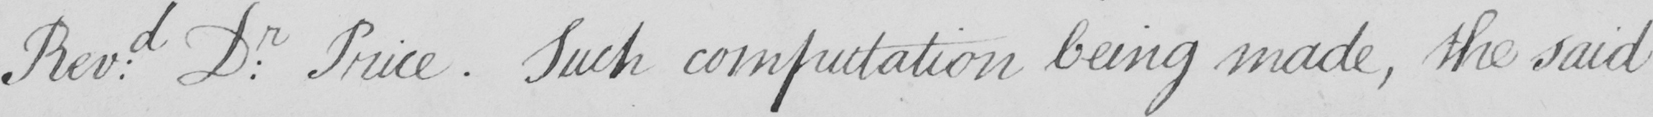Please provide the text content of this handwritten line. Revd . Dr . Price . Such computation being made , the said 